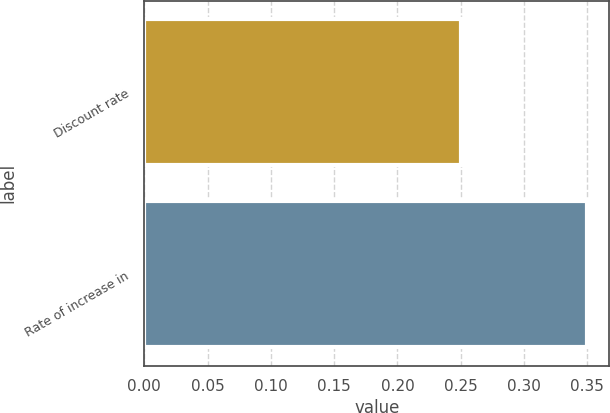Convert chart to OTSL. <chart><loc_0><loc_0><loc_500><loc_500><bar_chart><fcel>Discount rate<fcel>Rate of increase in<nl><fcel>0.25<fcel>0.35<nl></chart> 